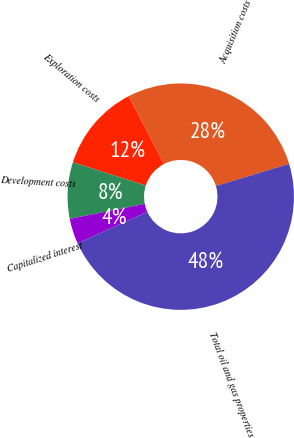Convert chart. <chart><loc_0><loc_0><loc_500><loc_500><pie_chart><fcel>Acquisition costs<fcel>Exploration costs<fcel>Development costs<fcel>Capitalized interest<fcel>Total oil and gas properties<nl><fcel>27.95%<fcel>12.48%<fcel>8.05%<fcel>3.62%<fcel>47.91%<nl></chart> 